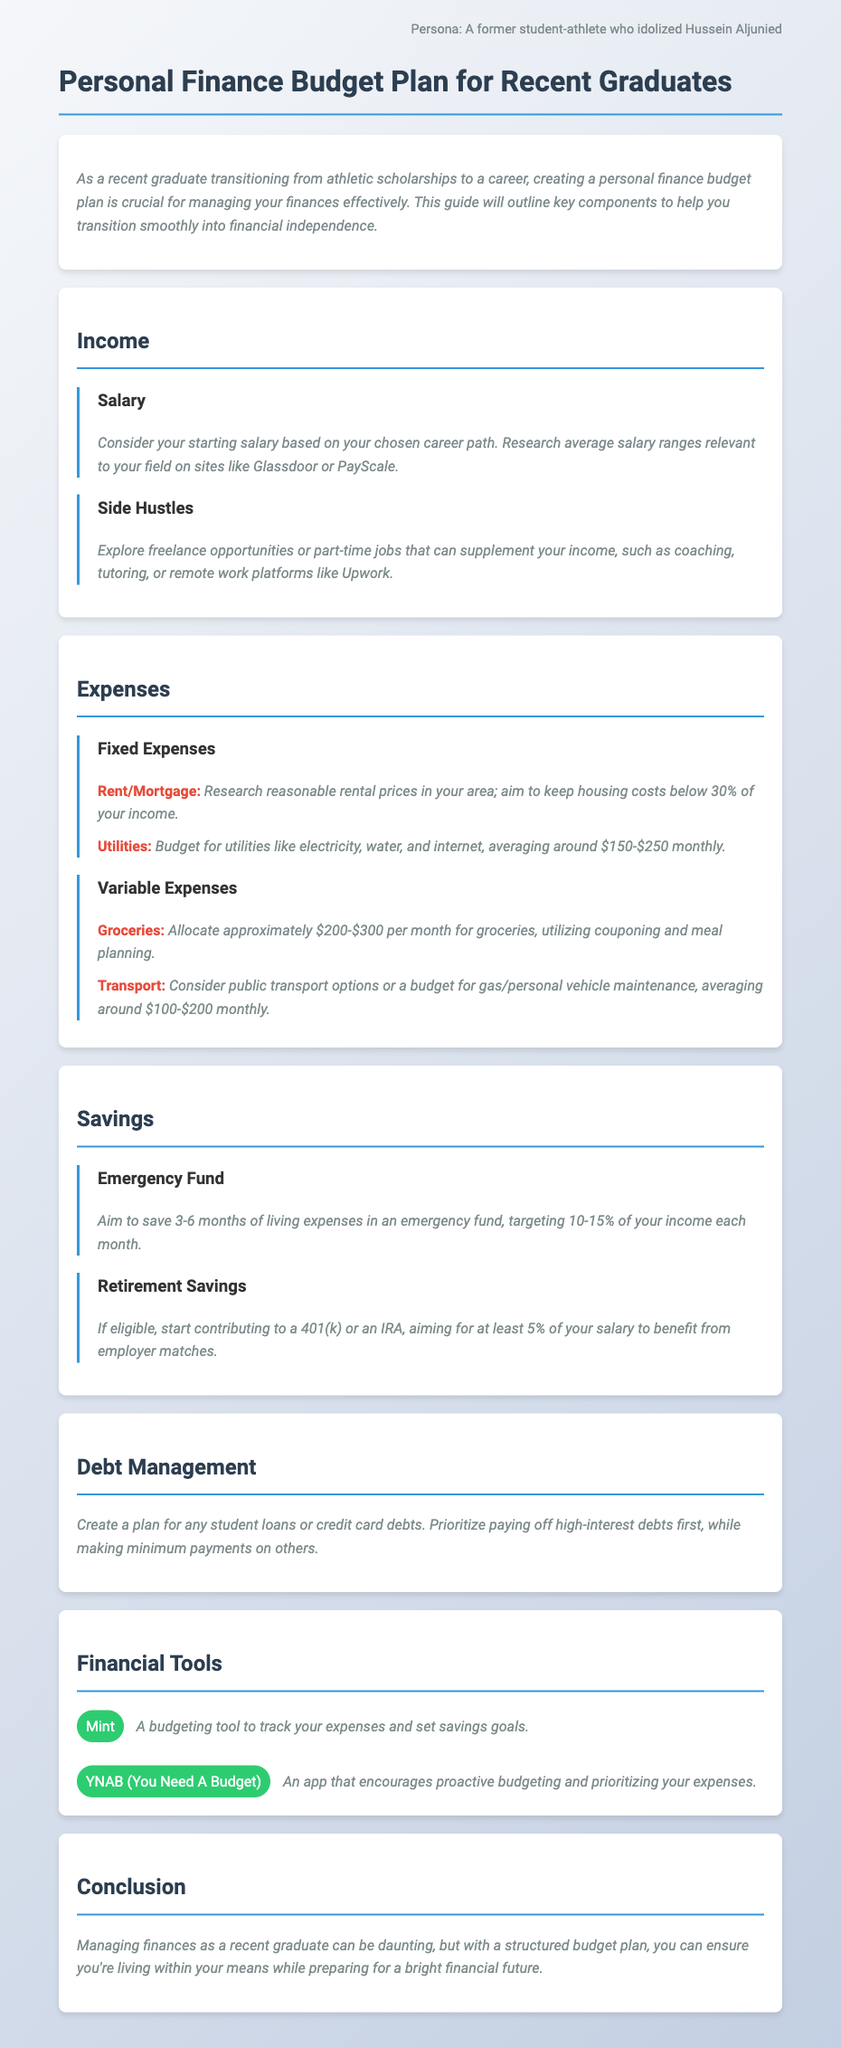What is the recommended percentage of income to allocate for housing costs? The document advises to aim to keep housing costs below 30% of your income.
Answer: 30% What is the suggested monthly budget for groceries? The note states that approximately $200-$300 per month should be allocated for groceries.
Answer: $200-$300 What financial tool is recommended for tracking expenses? The document mentions "Mint" as a budgeting tool for tracking expenses.
Answer: Mint What should you aim to save in an emergency fund? The note suggests saving 3-6 months of living expenses in an emergency fund.
Answer: 3-6 months What percentage of salary is recommended for retirement savings? The document recommends aiming for at least 5% of your salary for retirement savings.
Answer: 5% Which type of debts should you prioritize paying off first? The note advises prioritizing paying off high-interest debts first.
Answer: High-interest debts What is a potential side hustle mentioned in the plan? The document suggests exploring freelance opportunities or part-time jobs like coaching or tutoring.
Answer: Coaching What is the average budget for utilities? The document mentions budgeting around $150-$250 monthly for utilities.
Answer: $150-$250 